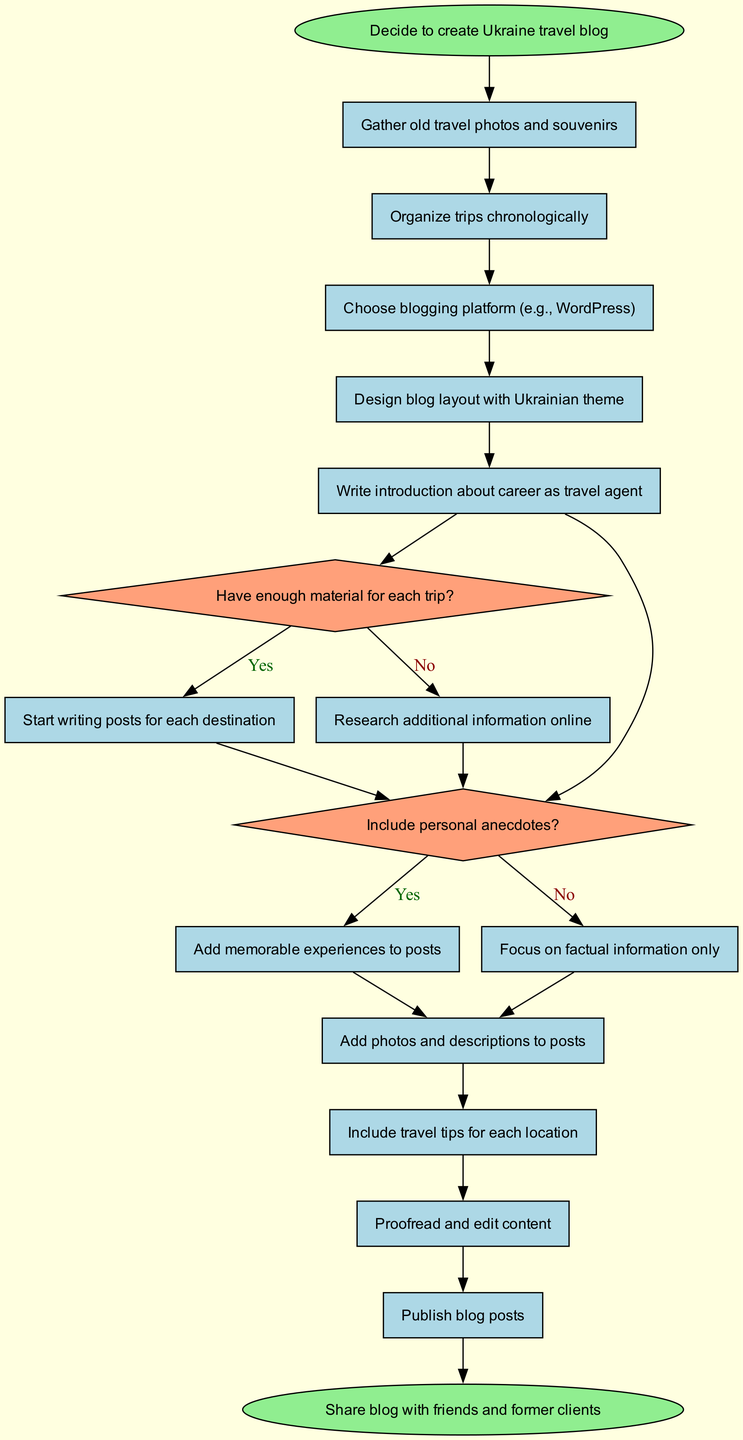What is the first process in the flowchart? The flowchart begins with the first process listed after the start node, which is "Gather old travel photos and souvenirs."
Answer: Gather old travel photos and souvenirs How many processes are there before the first decision point? There are five processes listed before the first decision, which include gathering photos, organizing trips, choosing a platform, designing layout, and writing an introduction.
Answer: Five What is the text of the first decision node? The first decision node poses the question, "Have enough material for each trip?" which determines the flow of the diagram.
Answer: Have enough material for each trip? What happens if there is not enough material for each trip? If there is not enough material, the flowchart directs to the action "Research additional information online."
Answer: Research additional information online What is the last process before reaching the end node? The last process outlined before concluding at the end node is "Publish blog posts." This is the final step taken in the progression of the flowchart.
Answer: Publish blog posts What follows the decision of including personal anecdotes? If the decision is made to include personal anecdotes ("Yes"), the next step is to "Add memorable experiences to posts." If "No," the focus will remain on factual information only.
Answer: Add memorable experiences to posts How many edges connect decisions to their corresponding yes/no outcomes? Each decision node in the flowchart has two outgoing edges, one for 'Yes' and another for 'No.' Since there are two decisions depicted, there would be a total of four edges connecting them to their respective outcomes.
Answer: Four What does the end node state? The final node at the end of the flowchart displays the concluding action, which is "Share blog with friends and former clients."
Answer: Share blog with friends and former clients 